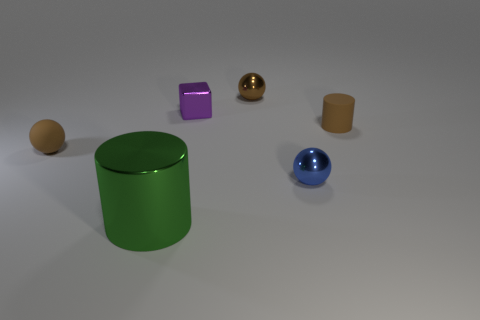Add 3 purple metal objects. How many objects exist? 9 Subtract all cylinders. How many objects are left? 4 Add 6 small blue metallic cubes. How many small blue metallic cubes exist? 6 Subtract 0 yellow cubes. How many objects are left? 6 Subtract all rubber things. Subtract all balls. How many objects are left? 1 Add 6 tiny purple things. How many tiny purple things are left? 7 